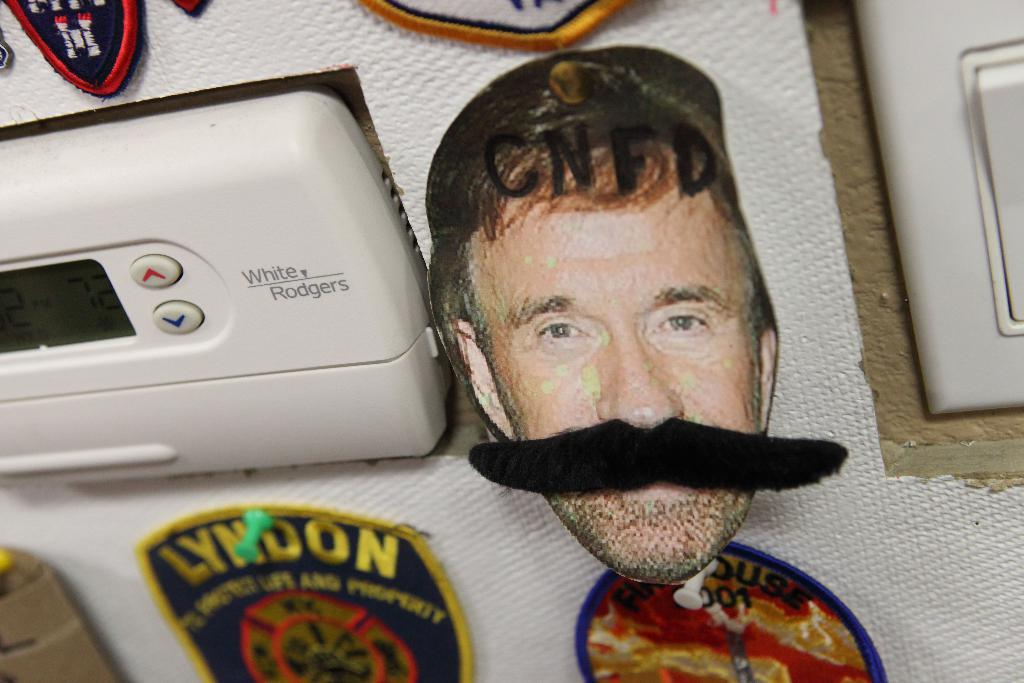<image>
Describe the image concisely. A picture of a man with a fake mustache on a bulletin board next to a White Rodgers thermostat. 